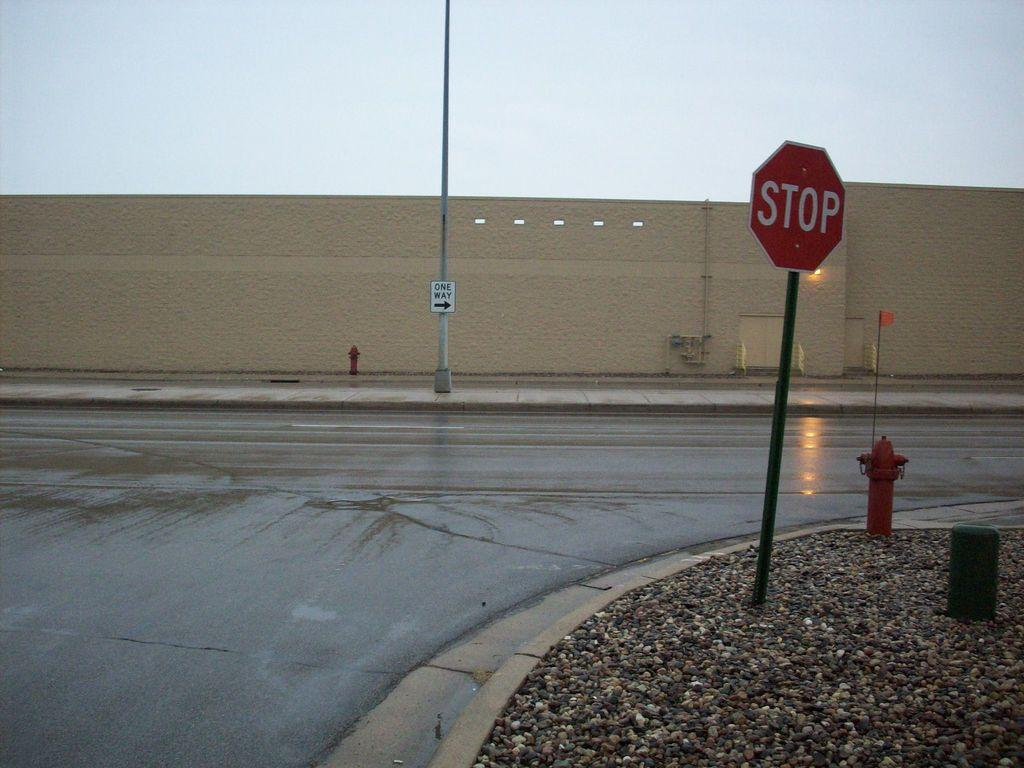<image>
Summarize the visual content of the image. A red STOP sign stands at a street corner next to a fire hydrant. 